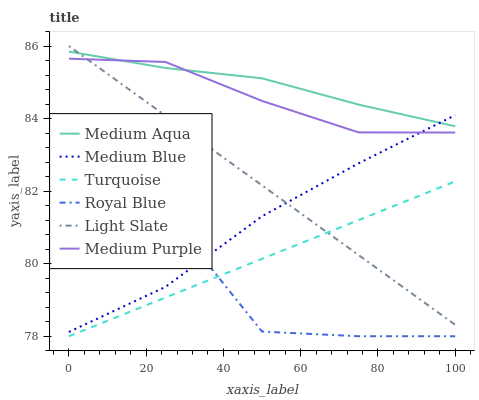Does Royal Blue have the minimum area under the curve?
Answer yes or no. Yes. Does Medium Aqua have the maximum area under the curve?
Answer yes or no. Yes. Does Light Slate have the minimum area under the curve?
Answer yes or no. No. Does Light Slate have the maximum area under the curve?
Answer yes or no. No. Is Light Slate the smoothest?
Answer yes or no. Yes. Is Royal Blue the roughest?
Answer yes or no. Yes. Is Medium Blue the smoothest?
Answer yes or no. No. Is Medium Blue the roughest?
Answer yes or no. No. Does Turquoise have the lowest value?
Answer yes or no. Yes. Does Light Slate have the lowest value?
Answer yes or no. No. Does Light Slate have the highest value?
Answer yes or no. Yes. Does Medium Blue have the highest value?
Answer yes or no. No. Is Turquoise less than Medium Aqua?
Answer yes or no. Yes. Is Medium Purple greater than Turquoise?
Answer yes or no. Yes. Does Light Slate intersect Turquoise?
Answer yes or no. Yes. Is Light Slate less than Turquoise?
Answer yes or no. No. Is Light Slate greater than Turquoise?
Answer yes or no. No. Does Turquoise intersect Medium Aqua?
Answer yes or no. No. 